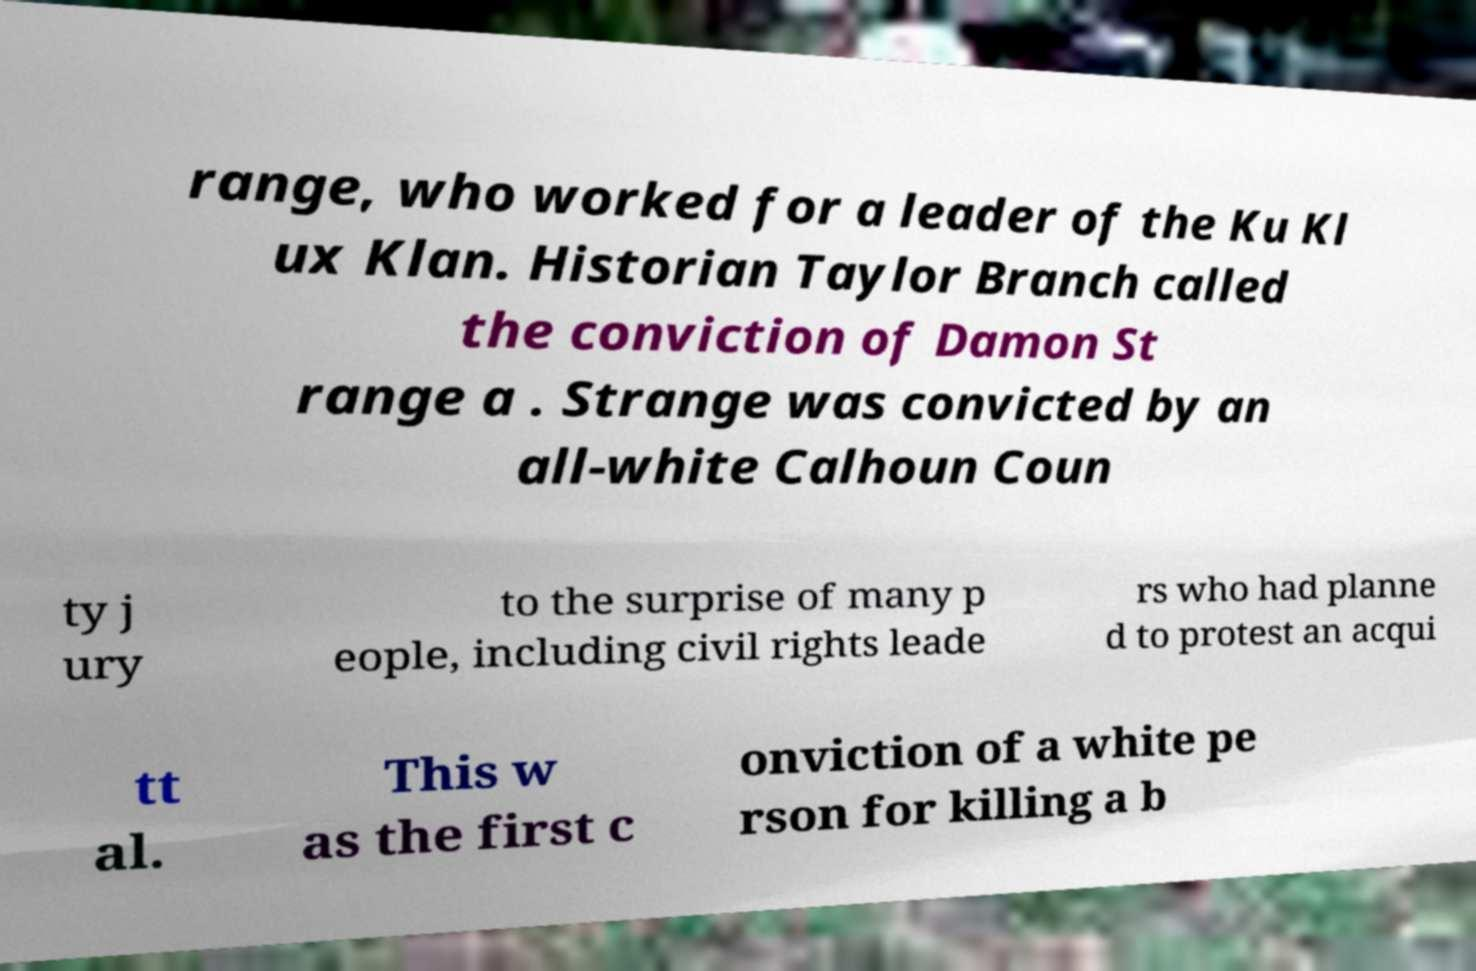I need the written content from this picture converted into text. Can you do that? range, who worked for a leader of the Ku Kl ux Klan. Historian Taylor Branch called the conviction of Damon St range a . Strange was convicted by an all-white Calhoun Coun ty j ury to the surprise of many p eople, including civil rights leade rs who had planne d to protest an acqui tt al. This w as the first c onviction of a white pe rson for killing a b 